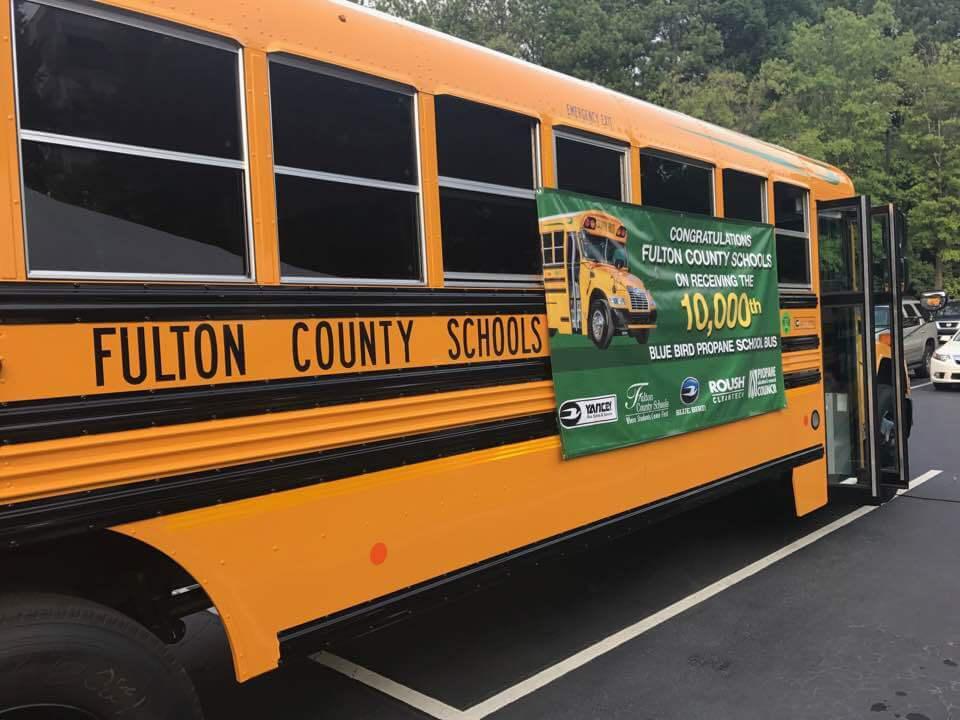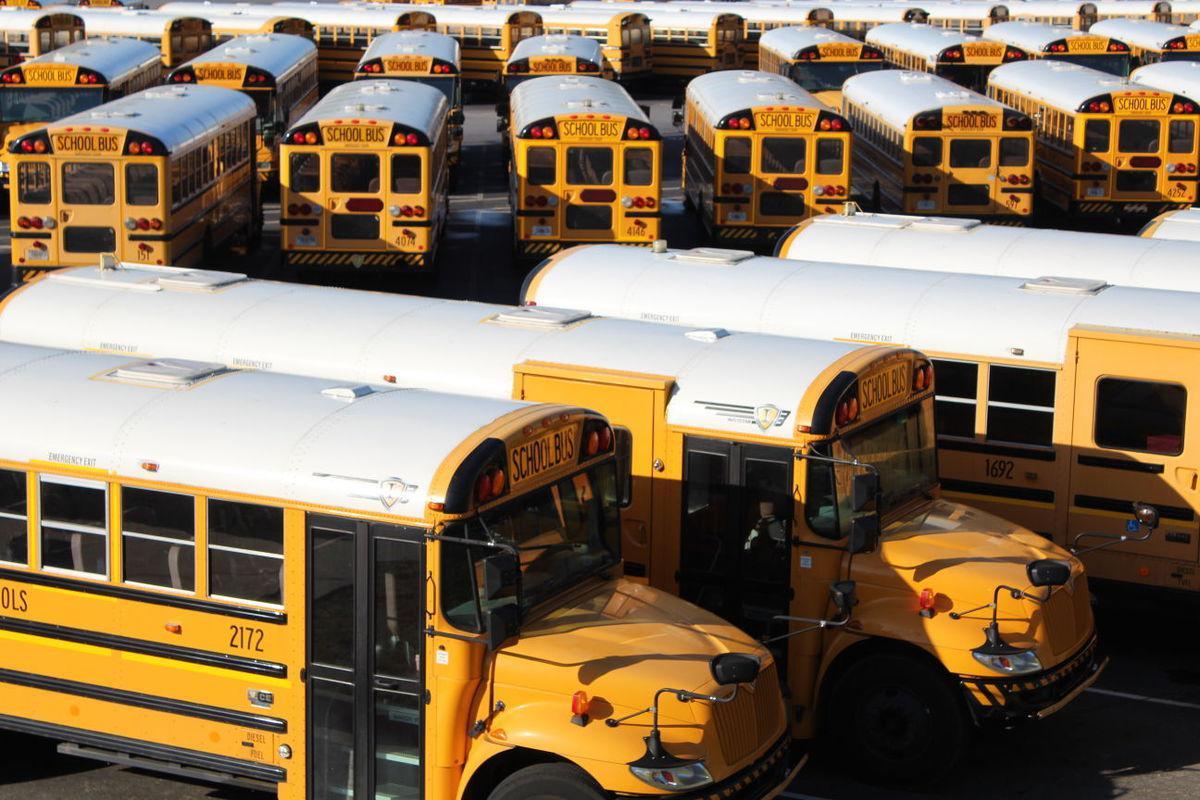The first image is the image on the left, the second image is the image on the right. Assess this claim about the two images: "The right image shows one flat-fronted bus displayed diagonally and forward-facing, and the left image includes at least one bus that has a non-flat front.". Correct or not? Answer yes or no. No. The first image is the image on the left, the second image is the image on the right. For the images shown, is this caption "There are more buses in the image on the left." true? Answer yes or no. No. 